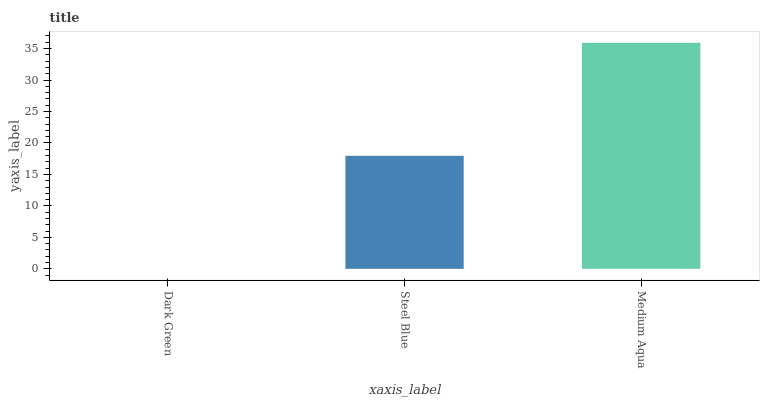Is Dark Green the minimum?
Answer yes or no. Yes. Is Medium Aqua the maximum?
Answer yes or no. Yes. Is Steel Blue the minimum?
Answer yes or no. No. Is Steel Blue the maximum?
Answer yes or no. No. Is Steel Blue greater than Dark Green?
Answer yes or no. Yes. Is Dark Green less than Steel Blue?
Answer yes or no. Yes. Is Dark Green greater than Steel Blue?
Answer yes or no. No. Is Steel Blue less than Dark Green?
Answer yes or no. No. Is Steel Blue the high median?
Answer yes or no. Yes. Is Steel Blue the low median?
Answer yes or no. Yes. Is Dark Green the high median?
Answer yes or no. No. Is Dark Green the low median?
Answer yes or no. No. 